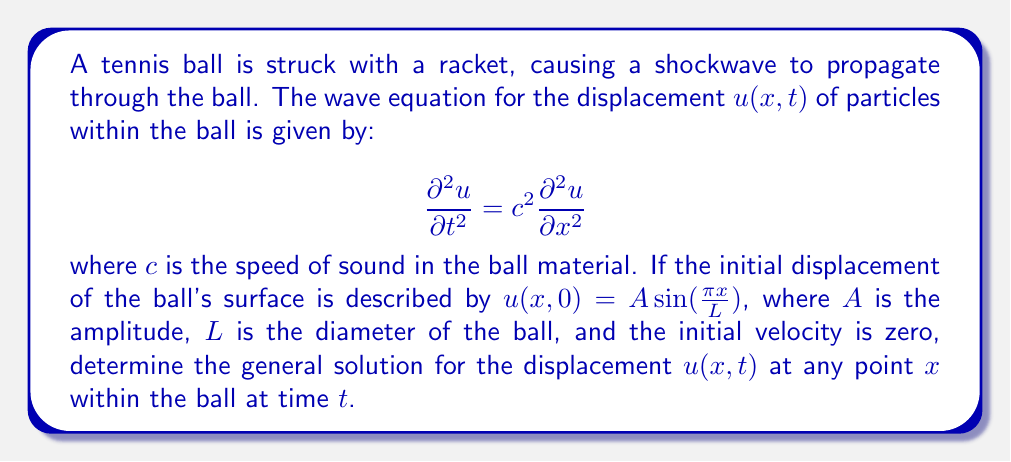What is the answer to this math problem? To solve this problem, we'll follow these steps:

1) The general solution to the 1D wave equation is given by D'Alembert's formula:

   $$u(x,t) = F(x-ct) + G(x+ct)$$

   where $F$ and $G$ are arbitrary functions determined by the initial conditions.

2) Given the initial conditions:
   
   $$u(x,0) = A \sin(\frac{\pi x}{L})$$
   $$\frac{\partial u}{\partial t}(x,0) = 0$$

3) From the first condition:

   $$F(x) + G(x) = A \sin(\frac{\pi x}{L})$$

4) From the second condition:

   $$-cF'(x) + cG'(x) = 0$$
   
   This implies $F'(x) = G'(x)$, so $F(x) = G(x) + \text{constant}$

5) Combining these results:

   $$2F(x) = A \sin(\frac{\pi x}{L}) + \text{constant}$$

   $$F(x) = \frac{A}{2} \sin(\frac{\pi x}{L}) + \text{constant}$$

   $$G(x) = \frac{A}{2} \sin(\frac{\pi x}{L}) - \text{constant}$$

6) The constant terms cancel out in the general solution, so we can ignore them.

7) Substituting back into D'Alembert's formula:

   $$u(x,t) = \frac{A}{2} \sin(\frac{\pi (x-ct)}{L}) + \frac{A}{2} \sin(\frac{\pi (x+ct)}{L})$$

8) Using the trigonometric identity for the sum of sines:

   $$\sin A + \sin B = 2 \sin(\frac{A+B}{2}) \cos(\frac{A-B}{2})$$

9) We get the final solution:

   $$u(x,t) = A \sin(\frac{\pi x}{L}) \cos(\frac{\pi ct}{L})$$

This solution represents a standing wave in the tennis ball, with the amplitude varying sinusoidally in both space and time.
Answer: $u(x,t) = A \sin(\frac{\pi x}{L}) \cos(\frac{\pi ct}{L})$ 